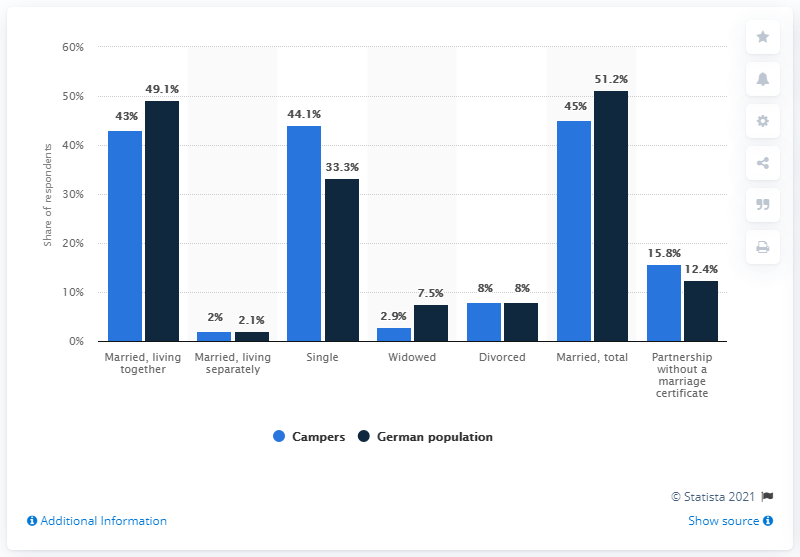Highlight a few significant elements in this photo. In 2020, approximately 49.1% of Germans were married and living together. 